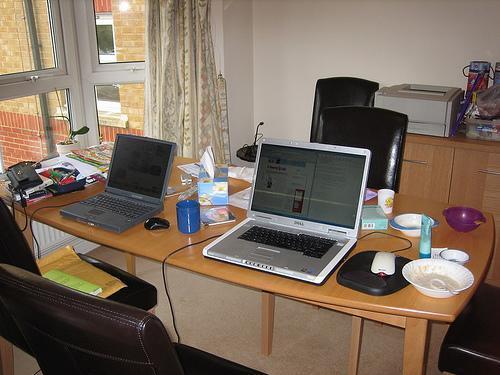How many comps are on the desk?
Give a very brief answer. 2. How many cups are on the desk?
Give a very brief answer. 2. How many laptops are there?
Give a very brief answer. 2. How many chairs are in the picture?
Give a very brief answer. 4. How many laptops can you see?
Give a very brief answer. 2. 